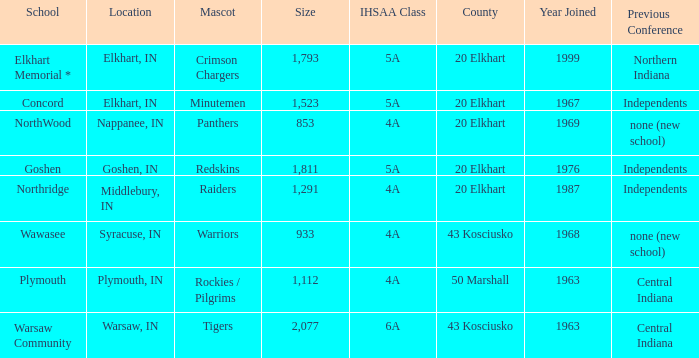What is the size of the team that was previously from Central Indiana conference, and is in IHSSA Class 4a? 1112.0. 